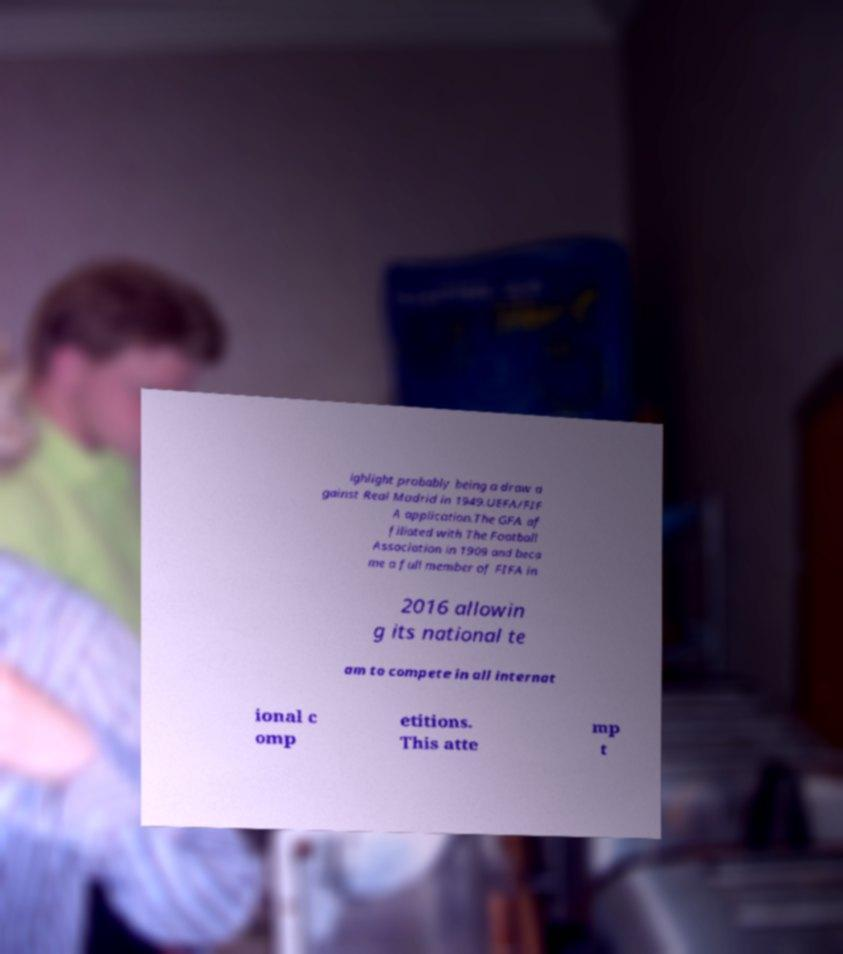There's text embedded in this image that I need extracted. Can you transcribe it verbatim? ighlight probably being a draw a gainst Real Madrid in 1949.UEFA/FIF A application.The GFA af filiated with The Football Association in 1909 and beca me a full member of FIFA in 2016 allowin g its national te am to compete in all internat ional c omp etitions. This atte mp t 